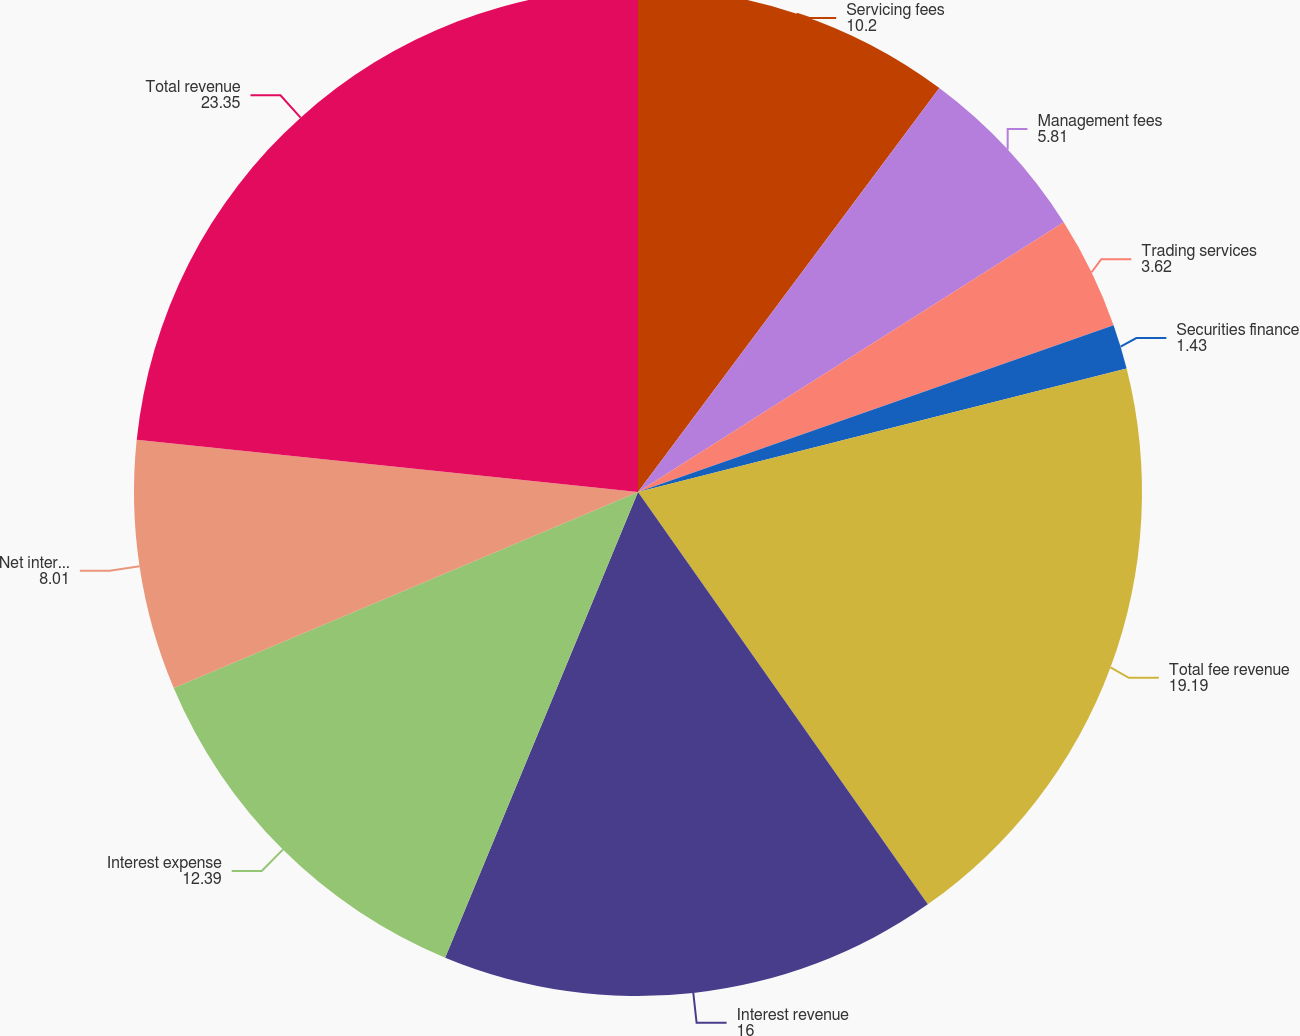Convert chart to OTSL. <chart><loc_0><loc_0><loc_500><loc_500><pie_chart><fcel>Servicing fees<fcel>Management fees<fcel>Trading services<fcel>Securities finance<fcel>Total fee revenue<fcel>Interest revenue<fcel>Interest expense<fcel>Net interest revenue<fcel>Total revenue<nl><fcel>10.2%<fcel>5.81%<fcel>3.62%<fcel>1.43%<fcel>19.19%<fcel>16.0%<fcel>12.39%<fcel>8.01%<fcel>23.35%<nl></chart> 